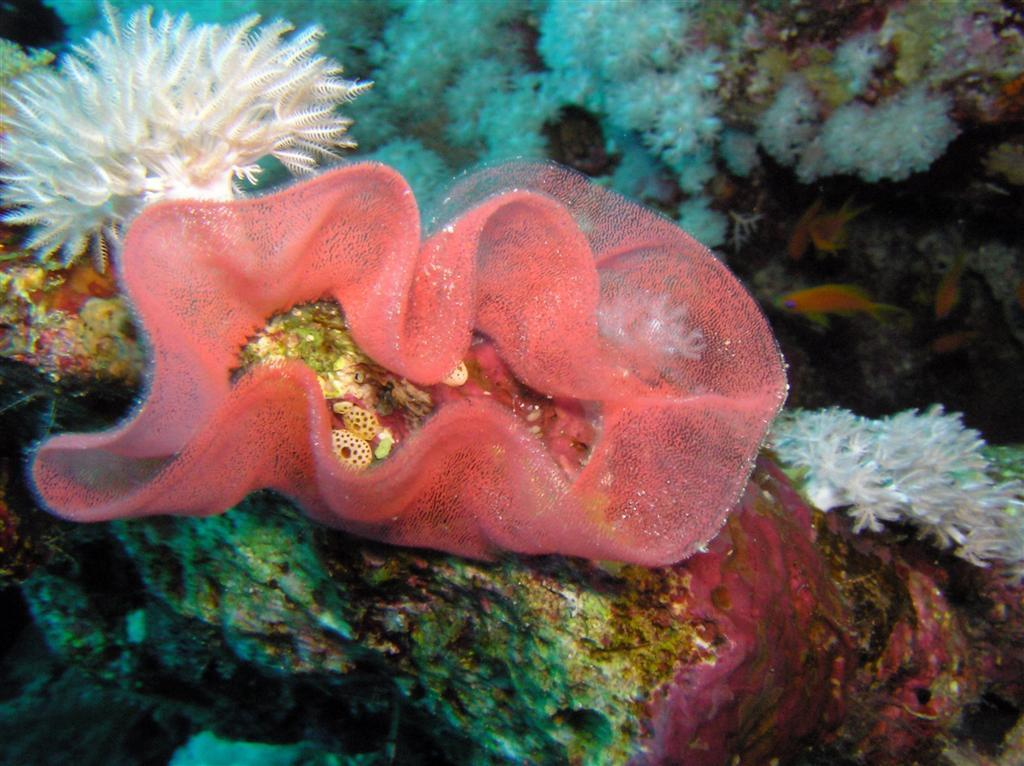What type of environment is shown in the image? The image depicts an underwater environment. What can be found in this underwater environment? There are corals and water plants in the image. What instrument is being played by the fish in the image? There are no fish or instruments present in the image; it depicts an underwater environment with corals and water plants. 